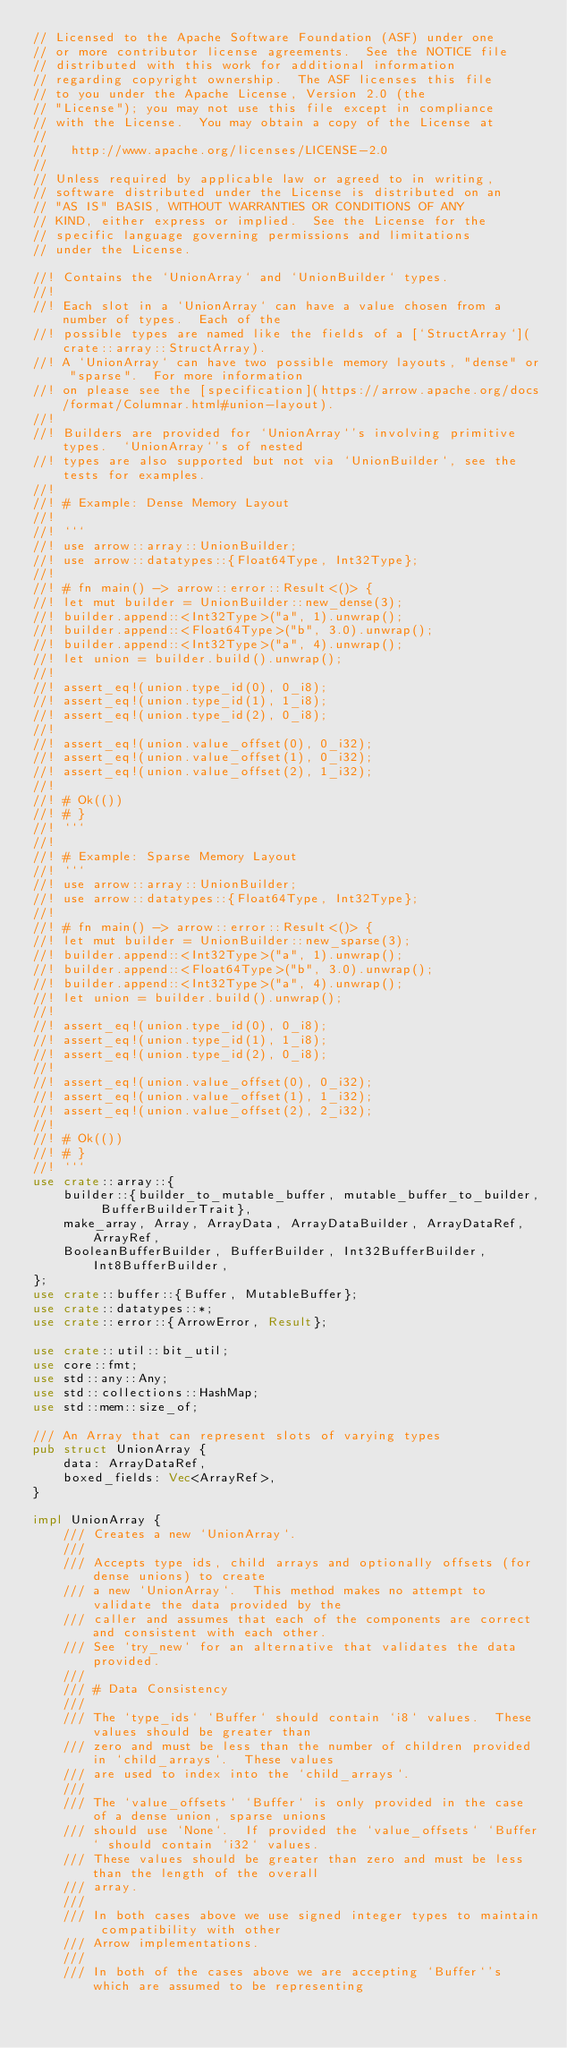<code> <loc_0><loc_0><loc_500><loc_500><_Rust_>// Licensed to the Apache Software Foundation (ASF) under one
// or more contributor license agreements.  See the NOTICE file
// distributed with this work for additional information
// regarding copyright ownership.  The ASF licenses this file
// to you under the Apache License, Version 2.0 (the
// "License"); you may not use this file except in compliance
// with the License.  You may obtain a copy of the License at
//
//   http://www.apache.org/licenses/LICENSE-2.0
//
// Unless required by applicable law or agreed to in writing,
// software distributed under the License is distributed on an
// "AS IS" BASIS, WITHOUT WARRANTIES OR CONDITIONS OF ANY
// KIND, either express or implied.  See the License for the
// specific language governing permissions and limitations
// under the License.

//! Contains the `UnionArray` and `UnionBuilder` types.
//!
//! Each slot in a `UnionArray` can have a value chosen from a number of types.  Each of the
//! possible types are named like the fields of a [`StructArray`](crate::array::StructArray).
//! A `UnionArray` can have two possible memory layouts, "dense" or "sparse".  For more information
//! on please see the [specification](https://arrow.apache.org/docs/format/Columnar.html#union-layout).
//!
//! Builders are provided for `UnionArray`'s involving primitive types.  `UnionArray`'s of nested
//! types are also supported but not via `UnionBuilder`, see the tests for examples.
//!
//! # Example: Dense Memory Layout
//!
//! ```
//! use arrow::array::UnionBuilder;
//! use arrow::datatypes::{Float64Type, Int32Type};
//!
//! # fn main() -> arrow::error::Result<()> {
//! let mut builder = UnionBuilder::new_dense(3);
//! builder.append::<Int32Type>("a", 1).unwrap();
//! builder.append::<Float64Type>("b", 3.0).unwrap();
//! builder.append::<Int32Type>("a", 4).unwrap();
//! let union = builder.build().unwrap();
//!
//! assert_eq!(union.type_id(0), 0_i8);
//! assert_eq!(union.type_id(1), 1_i8);
//! assert_eq!(union.type_id(2), 0_i8);
//!
//! assert_eq!(union.value_offset(0), 0_i32);
//! assert_eq!(union.value_offset(1), 0_i32);
//! assert_eq!(union.value_offset(2), 1_i32);
//!
//! # Ok(())
//! # }
//! ```
//!
//! # Example: Sparse Memory Layout
//! ```
//! use arrow::array::UnionBuilder;
//! use arrow::datatypes::{Float64Type, Int32Type};
//!
//! # fn main() -> arrow::error::Result<()> {
//! let mut builder = UnionBuilder::new_sparse(3);
//! builder.append::<Int32Type>("a", 1).unwrap();
//! builder.append::<Float64Type>("b", 3.0).unwrap();
//! builder.append::<Int32Type>("a", 4).unwrap();
//! let union = builder.build().unwrap();
//!
//! assert_eq!(union.type_id(0), 0_i8);
//! assert_eq!(union.type_id(1), 1_i8);
//! assert_eq!(union.type_id(2), 0_i8);
//!
//! assert_eq!(union.value_offset(0), 0_i32);
//! assert_eq!(union.value_offset(1), 1_i32);
//! assert_eq!(union.value_offset(2), 2_i32);
//!
//! # Ok(())
//! # }
//! ```
use crate::array::{
    builder::{builder_to_mutable_buffer, mutable_buffer_to_builder, BufferBuilderTrait},
    make_array, Array, ArrayData, ArrayDataBuilder, ArrayDataRef, ArrayRef,
    BooleanBufferBuilder, BufferBuilder, Int32BufferBuilder, Int8BufferBuilder,
};
use crate::buffer::{Buffer, MutableBuffer};
use crate::datatypes::*;
use crate::error::{ArrowError, Result};

use crate::util::bit_util;
use core::fmt;
use std::any::Any;
use std::collections::HashMap;
use std::mem::size_of;

/// An Array that can represent slots of varying types
pub struct UnionArray {
    data: ArrayDataRef,
    boxed_fields: Vec<ArrayRef>,
}

impl UnionArray {
    /// Creates a new `UnionArray`.
    ///
    /// Accepts type ids, child arrays and optionally offsets (for dense unions) to create
    /// a new `UnionArray`.  This method makes no attempt to validate the data provided by the
    /// caller and assumes that each of the components are correct and consistent with each other.
    /// See `try_new` for an alternative that validates the data provided.
    ///
    /// # Data Consistency
    ///
    /// The `type_ids` `Buffer` should contain `i8` values.  These values should be greater than
    /// zero and must be less than the number of children provided in `child_arrays`.  These values
    /// are used to index into the `child_arrays`.
    ///
    /// The `value_offsets` `Buffer` is only provided in the case of a dense union, sparse unions
    /// should use `None`.  If provided the `value_offsets` `Buffer` should contain `i32` values.
    /// These values should be greater than zero and must be less than the length of the overall
    /// array.
    ///
    /// In both cases above we use signed integer types to maintain compatibility with other
    /// Arrow implementations.
    ///
    /// In both of the cases above we are accepting `Buffer`'s which are assumed to be representing</code> 